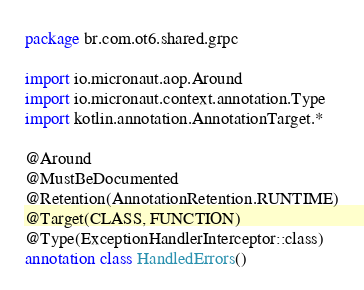<code> <loc_0><loc_0><loc_500><loc_500><_Kotlin_>package br.com.ot6.shared.grpc

import io.micronaut.aop.Around
import io.micronaut.context.annotation.Type
import kotlin.annotation.AnnotationTarget.*

@Around
@MustBeDocumented
@Retention(AnnotationRetention.RUNTIME)
@Target(CLASS, FUNCTION)
@Type(ExceptionHandlerInterceptor::class)
annotation class HandledErrors()
</code> 